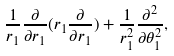<formula> <loc_0><loc_0><loc_500><loc_500>\frac { 1 } { r _ { 1 } } \frac { \partial } { \partial r _ { 1 } } ( r _ { 1 } \frac { \partial } { \partial r _ { 1 } } ) + \frac { 1 } { r _ { 1 } ^ { 2 } } \frac { \partial ^ { 2 } } { \partial \theta _ { 1 } ^ { 2 } } ,</formula> 